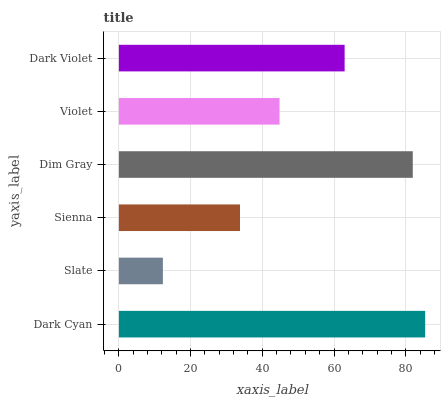Is Slate the minimum?
Answer yes or no. Yes. Is Dark Cyan the maximum?
Answer yes or no. Yes. Is Sienna the minimum?
Answer yes or no. No. Is Sienna the maximum?
Answer yes or no. No. Is Sienna greater than Slate?
Answer yes or no. Yes. Is Slate less than Sienna?
Answer yes or no. Yes. Is Slate greater than Sienna?
Answer yes or no. No. Is Sienna less than Slate?
Answer yes or no. No. Is Dark Violet the high median?
Answer yes or no. Yes. Is Violet the low median?
Answer yes or no. Yes. Is Sienna the high median?
Answer yes or no. No. Is Slate the low median?
Answer yes or no. No. 